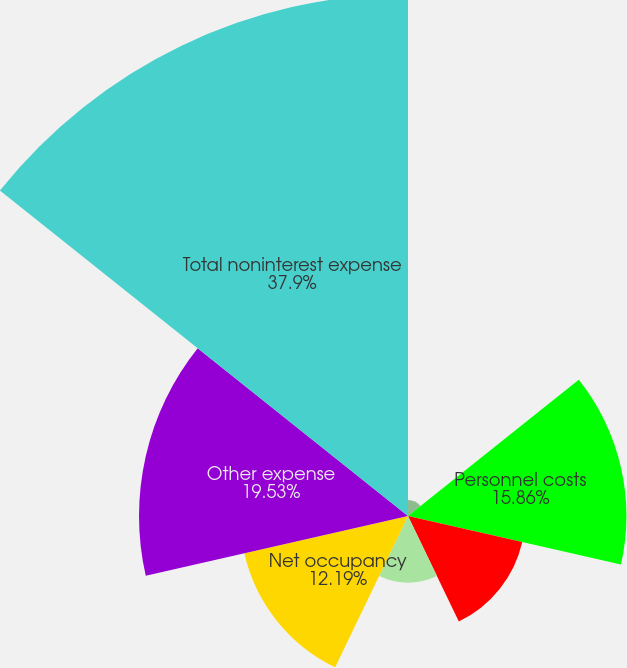Convert chart to OTSL. <chart><loc_0><loc_0><loc_500><loc_500><pie_chart><fcel>(dollar amounts in thousands)<fcel>Personnel costs<fcel>Outside data processing and<fcel>Equipment<fcel>Net occupancy<fcel>Other expense<fcel>Total noninterest expense<nl><fcel>1.17%<fcel>15.86%<fcel>8.51%<fcel>4.84%<fcel>12.19%<fcel>19.53%<fcel>37.9%<nl></chart> 